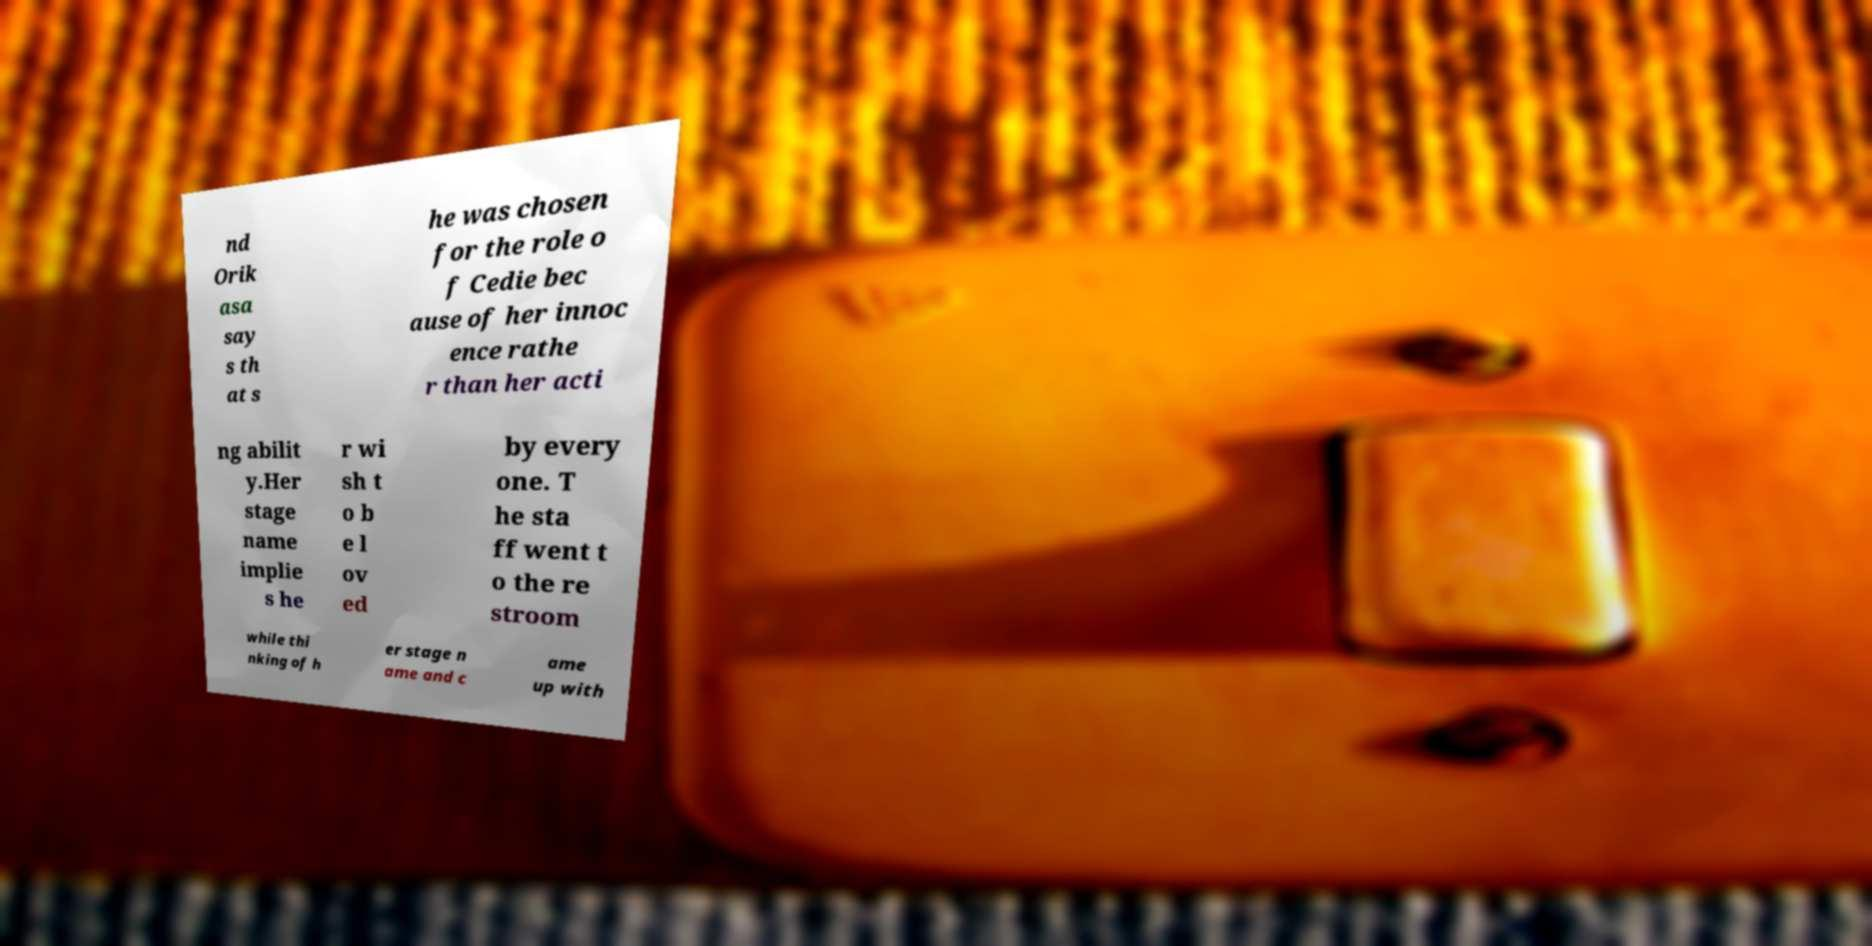Please read and relay the text visible in this image. What does it say? nd Orik asa say s th at s he was chosen for the role o f Cedie bec ause of her innoc ence rathe r than her acti ng abilit y.Her stage name implie s he r wi sh t o b e l ov ed by every one. T he sta ff went t o the re stroom while thi nking of h er stage n ame and c ame up with 